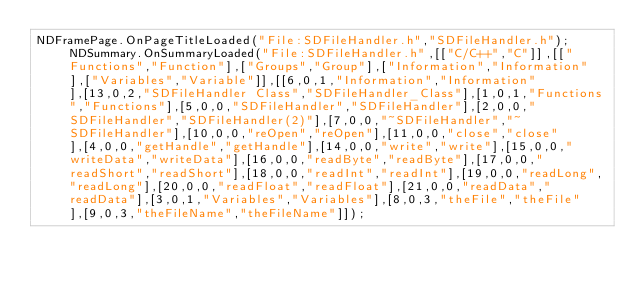Convert code to text. <code><loc_0><loc_0><loc_500><loc_500><_JavaScript_>NDFramePage.OnPageTitleLoaded("File:SDFileHandler.h","SDFileHandler.h");NDSummary.OnSummaryLoaded("File:SDFileHandler.h",[["C/C++","C"]],[["Functions","Function"],["Groups","Group"],["Information","Information"],["Variables","Variable"]],[[6,0,1,"Information","Information"],[13,0,2,"SDFileHandler Class","SDFileHandler_Class"],[1,0,1,"Functions","Functions"],[5,0,0,"SDFileHandler","SDFileHandler"],[2,0,0,"SDFileHandler","SDFileHandler(2)"],[7,0,0,"~SDFileHandler","~SDFileHandler"],[10,0,0,"reOpen","reOpen"],[11,0,0,"close","close"],[4,0,0,"getHandle","getHandle"],[14,0,0,"write","write"],[15,0,0,"writeData","writeData"],[16,0,0,"readByte","readByte"],[17,0,0,"readShort","readShort"],[18,0,0,"readInt","readInt"],[19,0,0,"readLong","readLong"],[20,0,0,"readFloat","readFloat"],[21,0,0,"readData","readData"],[3,0,1,"Variables","Variables"],[8,0,3,"theFile","theFile"],[9,0,3,"theFileName","theFileName"]]);</code> 